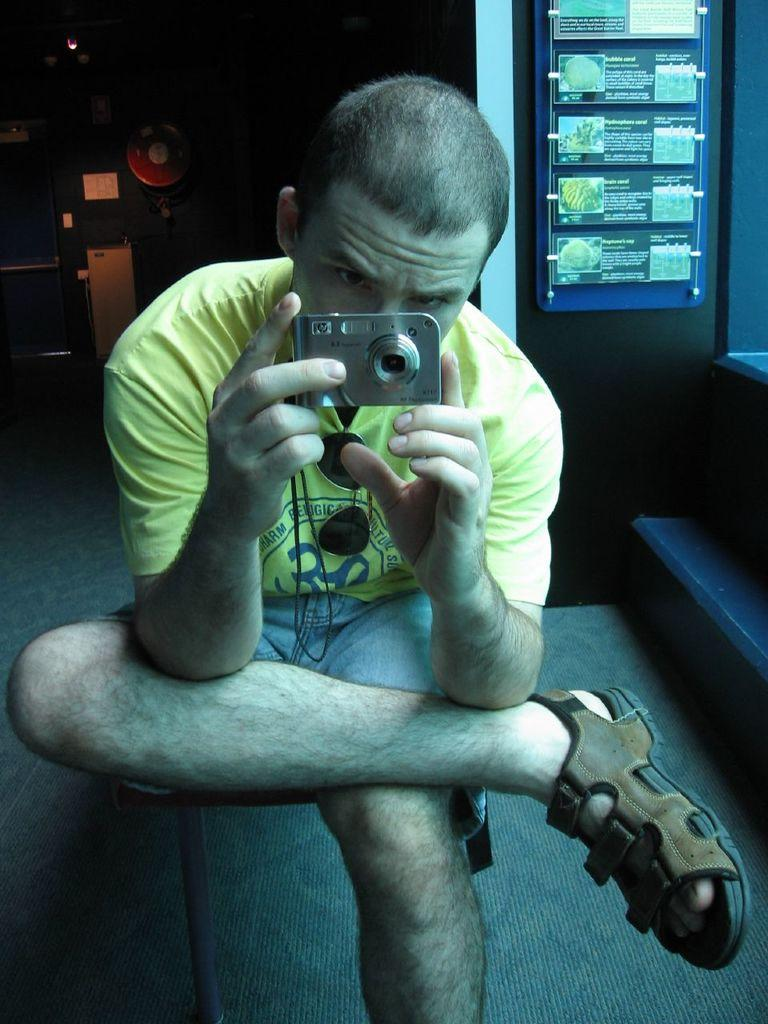Who is present in the image? There is a man in the image. What is the man doing in the image? The man is sitting on a chair in the image. What object is the man holding in his hand? The man is holding a camera in his hand. What type of feast is the man attending in the image? There is no feast present in the image; the man is simply sitting on a chair and holding a camera. Is the man playing baseball or volleyball in the image? No, the man is not playing baseball or volleyball in the image; he is sitting on a chair and holding a camera. 